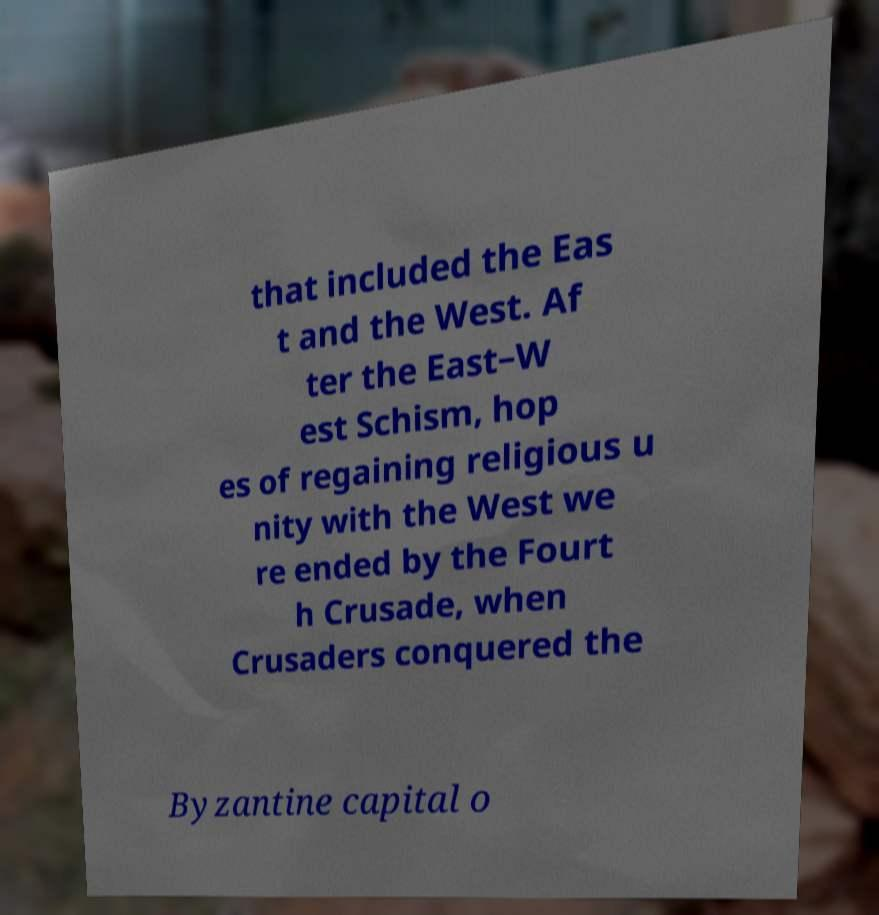Could you assist in decoding the text presented in this image and type it out clearly? that included the Eas t and the West. Af ter the East–W est Schism, hop es of regaining religious u nity with the West we re ended by the Fourt h Crusade, when Crusaders conquered the Byzantine capital o 